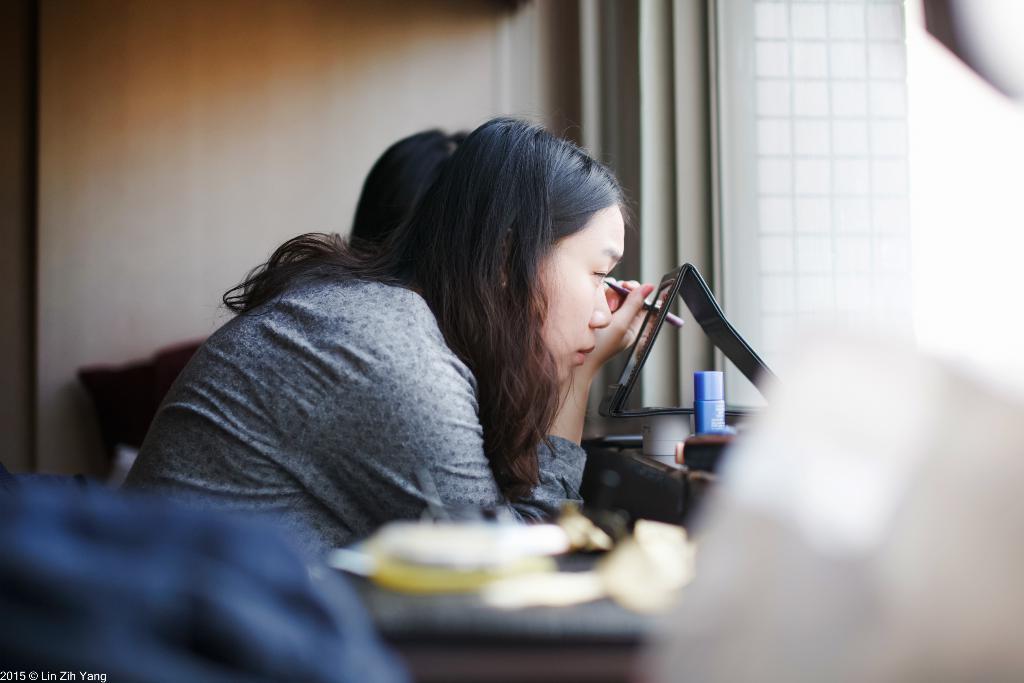In one or two sentences, can you explain what this image depicts? In the center of the image, we can see a lady holding eyebrow pencil in her hand and we can see a mirror, a bottle and some other person in the background. 